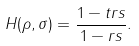Convert formula to latex. <formula><loc_0><loc_0><loc_500><loc_500>H ( \rho , \sigma ) = \frac { 1 - t r s } { 1 - r s } .</formula> 